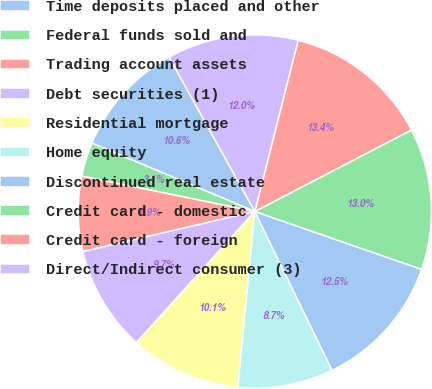<chart> <loc_0><loc_0><loc_500><loc_500><pie_chart><fcel>Time deposits placed and other<fcel>Federal funds sold and<fcel>Trading account assets<fcel>Debt securities (1)<fcel>Residential mortgage<fcel>Home equity<fcel>Discontinued real estate<fcel>Credit card - domestic<fcel>Credit card - foreign<fcel>Direct/Indirect consumer (3)<nl><fcel>10.61%<fcel>3.11%<fcel>6.86%<fcel>9.67%<fcel>10.14%<fcel>8.74%<fcel>12.48%<fcel>12.95%<fcel>13.42%<fcel>12.01%<nl></chart> 